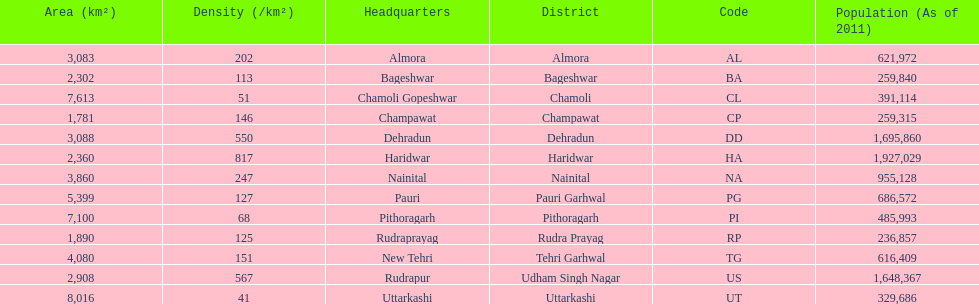If a person was headquartered in almora what would be his/her district? Almora. 